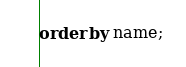<code> <loc_0><loc_0><loc_500><loc_500><_SQL_>order by name;</code> 